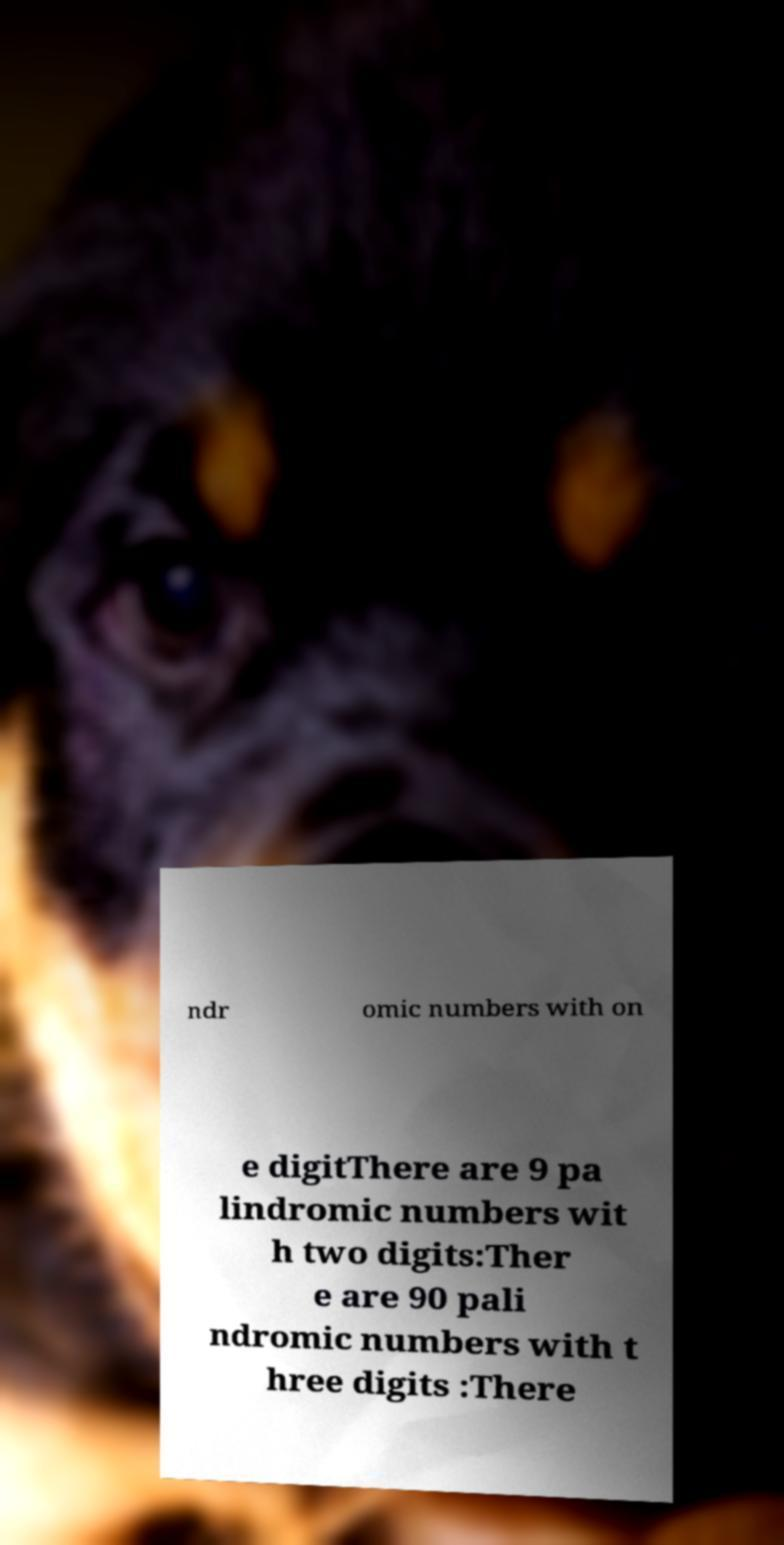Could you extract and type out the text from this image? ndr omic numbers with on e digitThere are 9 pa lindromic numbers wit h two digits:Ther e are 90 pali ndromic numbers with t hree digits :There 